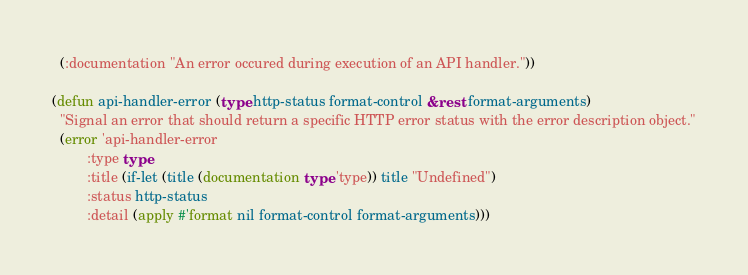Convert code to text. <code><loc_0><loc_0><loc_500><loc_500><_Lisp_>  (:documentation "An error occured during execution of an API handler."))

(defun api-handler-error (type http-status format-control &rest format-arguments)
  "Signal an error that should return a specific HTTP error status with the error description object."
  (error 'api-handler-error
         :type type
         :title (if-let (title (documentation type 'type)) title "Undefined")
         :status http-status
         :detail (apply #'format nil format-control format-arguments)))
</code> 